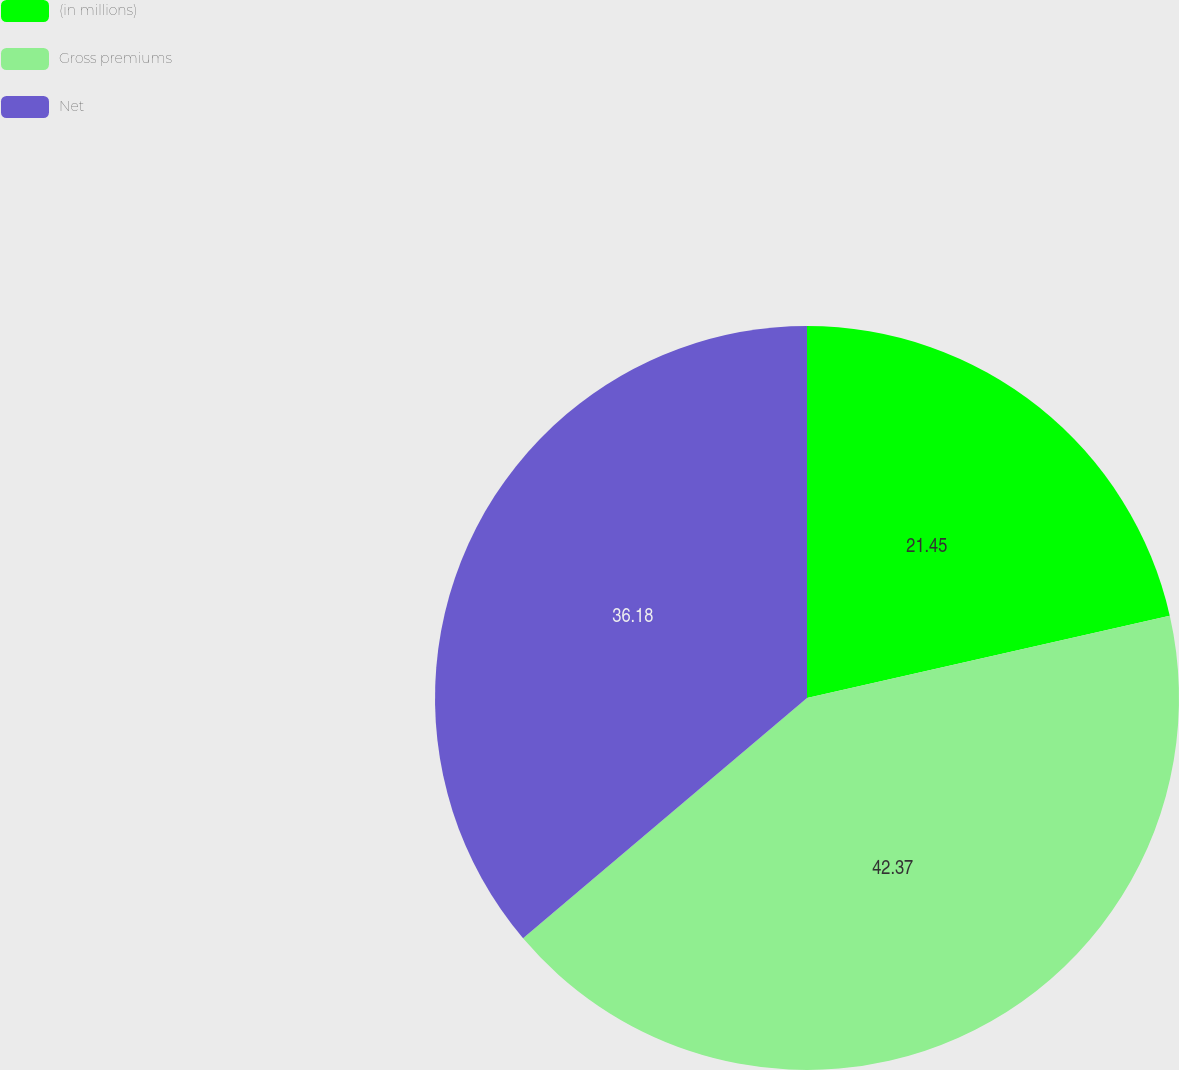<chart> <loc_0><loc_0><loc_500><loc_500><pie_chart><fcel>(in millions)<fcel>Gross premiums<fcel>Net<nl><fcel>21.45%<fcel>42.37%<fcel>36.18%<nl></chart> 